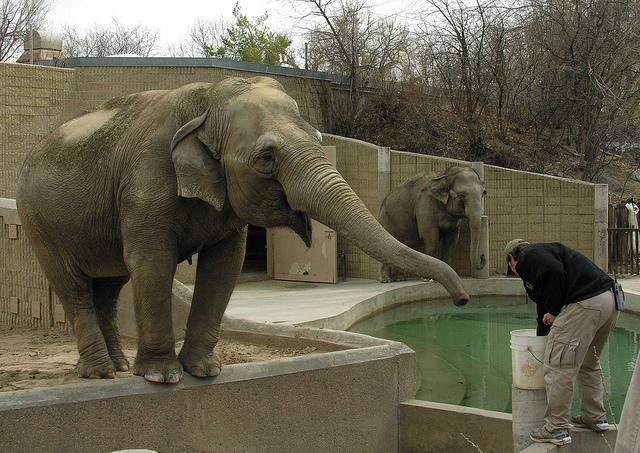How many elephants are there?
Give a very brief answer. 2. 